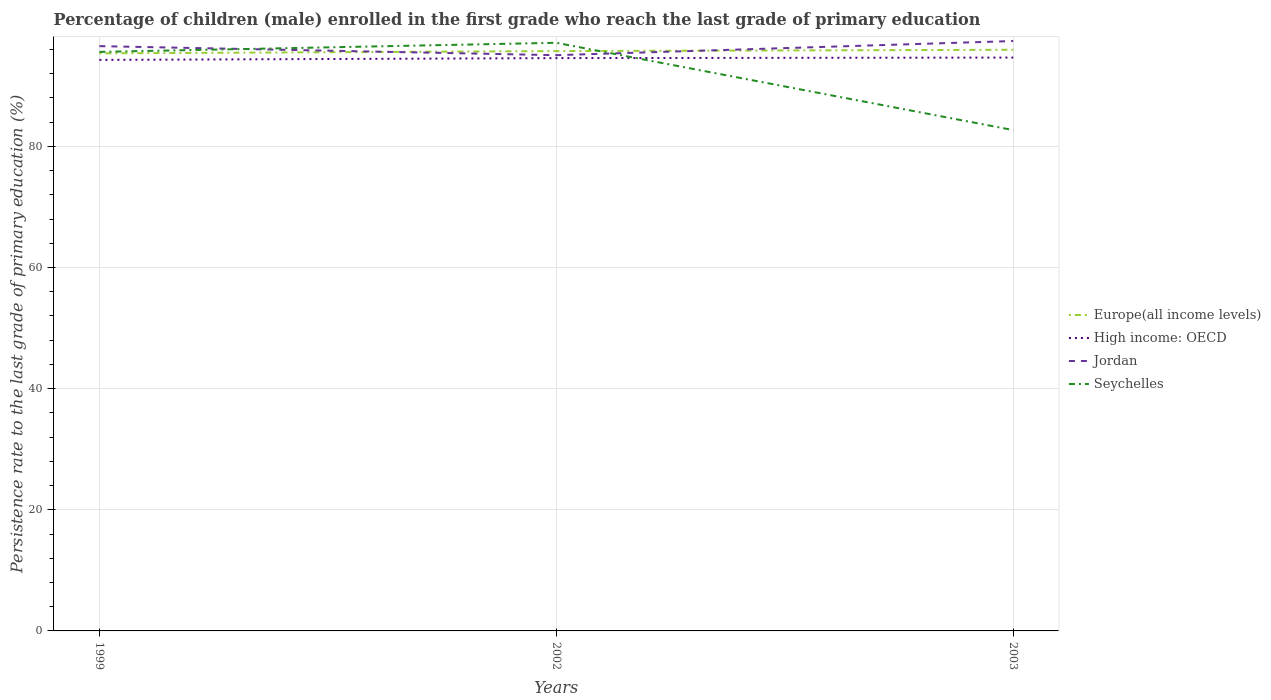Is the number of lines equal to the number of legend labels?
Your answer should be compact. Yes. Across all years, what is the maximum persistence rate of children in Europe(all income levels)?
Keep it short and to the point. 95.35. What is the total persistence rate of children in Seychelles in the graph?
Offer a terse response. 12.91. What is the difference between the highest and the second highest persistence rate of children in Europe(all income levels)?
Offer a terse response. 0.59. What is the difference between the highest and the lowest persistence rate of children in Seychelles?
Ensure brevity in your answer.  2. Is the persistence rate of children in Seychelles strictly greater than the persistence rate of children in Jordan over the years?
Ensure brevity in your answer.  No. What is the difference between two consecutive major ticks on the Y-axis?
Your answer should be very brief. 20. How many legend labels are there?
Provide a short and direct response. 4. How are the legend labels stacked?
Provide a succinct answer. Vertical. What is the title of the graph?
Offer a very short reply. Percentage of children (male) enrolled in the first grade who reach the last grade of primary education. What is the label or title of the Y-axis?
Make the answer very short. Persistence rate to the last grade of primary education (%). What is the Persistence rate to the last grade of primary education (%) in Europe(all income levels) in 1999?
Offer a terse response. 95.35. What is the Persistence rate to the last grade of primary education (%) in High income: OECD in 1999?
Your answer should be compact. 94.27. What is the Persistence rate to the last grade of primary education (%) in Jordan in 1999?
Provide a short and direct response. 96.55. What is the Persistence rate to the last grade of primary education (%) of Seychelles in 1999?
Keep it short and to the point. 95.59. What is the Persistence rate to the last grade of primary education (%) in Europe(all income levels) in 2002?
Your answer should be compact. 95.73. What is the Persistence rate to the last grade of primary education (%) in High income: OECD in 2002?
Offer a terse response. 94.57. What is the Persistence rate to the last grade of primary education (%) in Jordan in 2002?
Make the answer very short. 95.05. What is the Persistence rate to the last grade of primary education (%) of Seychelles in 2002?
Your answer should be compact. 97.1. What is the Persistence rate to the last grade of primary education (%) in Europe(all income levels) in 2003?
Ensure brevity in your answer.  95.94. What is the Persistence rate to the last grade of primary education (%) of High income: OECD in 2003?
Offer a very short reply. 94.66. What is the Persistence rate to the last grade of primary education (%) of Jordan in 2003?
Provide a short and direct response. 97.39. What is the Persistence rate to the last grade of primary education (%) in Seychelles in 2003?
Give a very brief answer. 82.68. Across all years, what is the maximum Persistence rate to the last grade of primary education (%) in Europe(all income levels)?
Offer a terse response. 95.94. Across all years, what is the maximum Persistence rate to the last grade of primary education (%) in High income: OECD?
Your response must be concise. 94.66. Across all years, what is the maximum Persistence rate to the last grade of primary education (%) of Jordan?
Give a very brief answer. 97.39. Across all years, what is the maximum Persistence rate to the last grade of primary education (%) in Seychelles?
Your response must be concise. 97.1. Across all years, what is the minimum Persistence rate to the last grade of primary education (%) in Europe(all income levels)?
Provide a short and direct response. 95.35. Across all years, what is the minimum Persistence rate to the last grade of primary education (%) of High income: OECD?
Your response must be concise. 94.27. Across all years, what is the minimum Persistence rate to the last grade of primary education (%) of Jordan?
Make the answer very short. 95.05. Across all years, what is the minimum Persistence rate to the last grade of primary education (%) of Seychelles?
Keep it short and to the point. 82.68. What is the total Persistence rate to the last grade of primary education (%) in Europe(all income levels) in the graph?
Your answer should be very brief. 287.02. What is the total Persistence rate to the last grade of primary education (%) in High income: OECD in the graph?
Offer a very short reply. 283.5. What is the total Persistence rate to the last grade of primary education (%) in Jordan in the graph?
Your response must be concise. 288.98. What is the total Persistence rate to the last grade of primary education (%) in Seychelles in the graph?
Your response must be concise. 275.37. What is the difference between the Persistence rate to the last grade of primary education (%) in Europe(all income levels) in 1999 and that in 2002?
Keep it short and to the point. -0.37. What is the difference between the Persistence rate to the last grade of primary education (%) of High income: OECD in 1999 and that in 2002?
Your answer should be compact. -0.29. What is the difference between the Persistence rate to the last grade of primary education (%) in Jordan in 1999 and that in 2002?
Provide a succinct answer. 1.49. What is the difference between the Persistence rate to the last grade of primary education (%) in Seychelles in 1999 and that in 2002?
Give a very brief answer. -1.5. What is the difference between the Persistence rate to the last grade of primary education (%) in Europe(all income levels) in 1999 and that in 2003?
Give a very brief answer. -0.59. What is the difference between the Persistence rate to the last grade of primary education (%) of High income: OECD in 1999 and that in 2003?
Keep it short and to the point. -0.39. What is the difference between the Persistence rate to the last grade of primary education (%) in Jordan in 1999 and that in 2003?
Give a very brief answer. -0.84. What is the difference between the Persistence rate to the last grade of primary education (%) in Seychelles in 1999 and that in 2003?
Provide a succinct answer. 12.91. What is the difference between the Persistence rate to the last grade of primary education (%) of Europe(all income levels) in 2002 and that in 2003?
Keep it short and to the point. -0.22. What is the difference between the Persistence rate to the last grade of primary education (%) in High income: OECD in 2002 and that in 2003?
Your response must be concise. -0.09. What is the difference between the Persistence rate to the last grade of primary education (%) of Jordan in 2002 and that in 2003?
Make the answer very short. -2.34. What is the difference between the Persistence rate to the last grade of primary education (%) in Seychelles in 2002 and that in 2003?
Make the answer very short. 14.41. What is the difference between the Persistence rate to the last grade of primary education (%) of Europe(all income levels) in 1999 and the Persistence rate to the last grade of primary education (%) of High income: OECD in 2002?
Keep it short and to the point. 0.79. What is the difference between the Persistence rate to the last grade of primary education (%) of Europe(all income levels) in 1999 and the Persistence rate to the last grade of primary education (%) of Jordan in 2002?
Provide a short and direct response. 0.3. What is the difference between the Persistence rate to the last grade of primary education (%) of Europe(all income levels) in 1999 and the Persistence rate to the last grade of primary education (%) of Seychelles in 2002?
Provide a short and direct response. -1.74. What is the difference between the Persistence rate to the last grade of primary education (%) of High income: OECD in 1999 and the Persistence rate to the last grade of primary education (%) of Jordan in 2002?
Offer a very short reply. -0.78. What is the difference between the Persistence rate to the last grade of primary education (%) in High income: OECD in 1999 and the Persistence rate to the last grade of primary education (%) in Seychelles in 2002?
Provide a short and direct response. -2.82. What is the difference between the Persistence rate to the last grade of primary education (%) in Jordan in 1999 and the Persistence rate to the last grade of primary education (%) in Seychelles in 2002?
Offer a terse response. -0.55. What is the difference between the Persistence rate to the last grade of primary education (%) of Europe(all income levels) in 1999 and the Persistence rate to the last grade of primary education (%) of High income: OECD in 2003?
Make the answer very short. 0.69. What is the difference between the Persistence rate to the last grade of primary education (%) in Europe(all income levels) in 1999 and the Persistence rate to the last grade of primary education (%) in Jordan in 2003?
Offer a very short reply. -2.04. What is the difference between the Persistence rate to the last grade of primary education (%) of Europe(all income levels) in 1999 and the Persistence rate to the last grade of primary education (%) of Seychelles in 2003?
Give a very brief answer. 12.67. What is the difference between the Persistence rate to the last grade of primary education (%) in High income: OECD in 1999 and the Persistence rate to the last grade of primary education (%) in Jordan in 2003?
Provide a succinct answer. -3.12. What is the difference between the Persistence rate to the last grade of primary education (%) of High income: OECD in 1999 and the Persistence rate to the last grade of primary education (%) of Seychelles in 2003?
Keep it short and to the point. 11.59. What is the difference between the Persistence rate to the last grade of primary education (%) of Jordan in 1999 and the Persistence rate to the last grade of primary education (%) of Seychelles in 2003?
Make the answer very short. 13.86. What is the difference between the Persistence rate to the last grade of primary education (%) in Europe(all income levels) in 2002 and the Persistence rate to the last grade of primary education (%) in High income: OECD in 2003?
Your answer should be very brief. 1.07. What is the difference between the Persistence rate to the last grade of primary education (%) in Europe(all income levels) in 2002 and the Persistence rate to the last grade of primary education (%) in Jordan in 2003?
Offer a terse response. -1.66. What is the difference between the Persistence rate to the last grade of primary education (%) of Europe(all income levels) in 2002 and the Persistence rate to the last grade of primary education (%) of Seychelles in 2003?
Make the answer very short. 13.04. What is the difference between the Persistence rate to the last grade of primary education (%) of High income: OECD in 2002 and the Persistence rate to the last grade of primary education (%) of Jordan in 2003?
Provide a short and direct response. -2.82. What is the difference between the Persistence rate to the last grade of primary education (%) of High income: OECD in 2002 and the Persistence rate to the last grade of primary education (%) of Seychelles in 2003?
Provide a short and direct response. 11.88. What is the difference between the Persistence rate to the last grade of primary education (%) of Jordan in 2002 and the Persistence rate to the last grade of primary education (%) of Seychelles in 2003?
Give a very brief answer. 12.37. What is the average Persistence rate to the last grade of primary education (%) of Europe(all income levels) per year?
Give a very brief answer. 95.67. What is the average Persistence rate to the last grade of primary education (%) in High income: OECD per year?
Give a very brief answer. 94.5. What is the average Persistence rate to the last grade of primary education (%) of Jordan per year?
Your response must be concise. 96.33. What is the average Persistence rate to the last grade of primary education (%) of Seychelles per year?
Your response must be concise. 91.79. In the year 1999, what is the difference between the Persistence rate to the last grade of primary education (%) in Europe(all income levels) and Persistence rate to the last grade of primary education (%) in High income: OECD?
Offer a terse response. 1.08. In the year 1999, what is the difference between the Persistence rate to the last grade of primary education (%) in Europe(all income levels) and Persistence rate to the last grade of primary education (%) in Jordan?
Your response must be concise. -1.19. In the year 1999, what is the difference between the Persistence rate to the last grade of primary education (%) of Europe(all income levels) and Persistence rate to the last grade of primary education (%) of Seychelles?
Offer a terse response. -0.24. In the year 1999, what is the difference between the Persistence rate to the last grade of primary education (%) of High income: OECD and Persistence rate to the last grade of primary education (%) of Jordan?
Give a very brief answer. -2.27. In the year 1999, what is the difference between the Persistence rate to the last grade of primary education (%) in High income: OECD and Persistence rate to the last grade of primary education (%) in Seychelles?
Give a very brief answer. -1.32. In the year 1999, what is the difference between the Persistence rate to the last grade of primary education (%) of Jordan and Persistence rate to the last grade of primary education (%) of Seychelles?
Your answer should be compact. 0.95. In the year 2002, what is the difference between the Persistence rate to the last grade of primary education (%) in Europe(all income levels) and Persistence rate to the last grade of primary education (%) in High income: OECD?
Keep it short and to the point. 1.16. In the year 2002, what is the difference between the Persistence rate to the last grade of primary education (%) of Europe(all income levels) and Persistence rate to the last grade of primary education (%) of Jordan?
Keep it short and to the point. 0.68. In the year 2002, what is the difference between the Persistence rate to the last grade of primary education (%) in Europe(all income levels) and Persistence rate to the last grade of primary education (%) in Seychelles?
Provide a succinct answer. -1.37. In the year 2002, what is the difference between the Persistence rate to the last grade of primary education (%) of High income: OECD and Persistence rate to the last grade of primary education (%) of Jordan?
Give a very brief answer. -0.48. In the year 2002, what is the difference between the Persistence rate to the last grade of primary education (%) in High income: OECD and Persistence rate to the last grade of primary education (%) in Seychelles?
Your answer should be compact. -2.53. In the year 2002, what is the difference between the Persistence rate to the last grade of primary education (%) in Jordan and Persistence rate to the last grade of primary education (%) in Seychelles?
Offer a terse response. -2.04. In the year 2003, what is the difference between the Persistence rate to the last grade of primary education (%) of Europe(all income levels) and Persistence rate to the last grade of primary education (%) of High income: OECD?
Keep it short and to the point. 1.28. In the year 2003, what is the difference between the Persistence rate to the last grade of primary education (%) of Europe(all income levels) and Persistence rate to the last grade of primary education (%) of Jordan?
Your answer should be very brief. -1.45. In the year 2003, what is the difference between the Persistence rate to the last grade of primary education (%) in Europe(all income levels) and Persistence rate to the last grade of primary education (%) in Seychelles?
Provide a short and direct response. 13.26. In the year 2003, what is the difference between the Persistence rate to the last grade of primary education (%) in High income: OECD and Persistence rate to the last grade of primary education (%) in Jordan?
Your response must be concise. -2.73. In the year 2003, what is the difference between the Persistence rate to the last grade of primary education (%) of High income: OECD and Persistence rate to the last grade of primary education (%) of Seychelles?
Your answer should be compact. 11.97. In the year 2003, what is the difference between the Persistence rate to the last grade of primary education (%) of Jordan and Persistence rate to the last grade of primary education (%) of Seychelles?
Your answer should be very brief. 14.7. What is the ratio of the Persistence rate to the last grade of primary education (%) of Jordan in 1999 to that in 2002?
Your answer should be compact. 1.02. What is the ratio of the Persistence rate to the last grade of primary education (%) in Seychelles in 1999 to that in 2002?
Make the answer very short. 0.98. What is the ratio of the Persistence rate to the last grade of primary education (%) in Europe(all income levels) in 1999 to that in 2003?
Provide a succinct answer. 0.99. What is the ratio of the Persistence rate to the last grade of primary education (%) of Seychelles in 1999 to that in 2003?
Offer a terse response. 1.16. What is the ratio of the Persistence rate to the last grade of primary education (%) of Seychelles in 2002 to that in 2003?
Make the answer very short. 1.17. What is the difference between the highest and the second highest Persistence rate to the last grade of primary education (%) in Europe(all income levels)?
Make the answer very short. 0.22. What is the difference between the highest and the second highest Persistence rate to the last grade of primary education (%) of High income: OECD?
Offer a very short reply. 0.09. What is the difference between the highest and the second highest Persistence rate to the last grade of primary education (%) of Jordan?
Your response must be concise. 0.84. What is the difference between the highest and the second highest Persistence rate to the last grade of primary education (%) in Seychelles?
Offer a terse response. 1.5. What is the difference between the highest and the lowest Persistence rate to the last grade of primary education (%) in Europe(all income levels)?
Offer a terse response. 0.59. What is the difference between the highest and the lowest Persistence rate to the last grade of primary education (%) in High income: OECD?
Ensure brevity in your answer.  0.39. What is the difference between the highest and the lowest Persistence rate to the last grade of primary education (%) of Jordan?
Provide a short and direct response. 2.34. What is the difference between the highest and the lowest Persistence rate to the last grade of primary education (%) in Seychelles?
Make the answer very short. 14.41. 